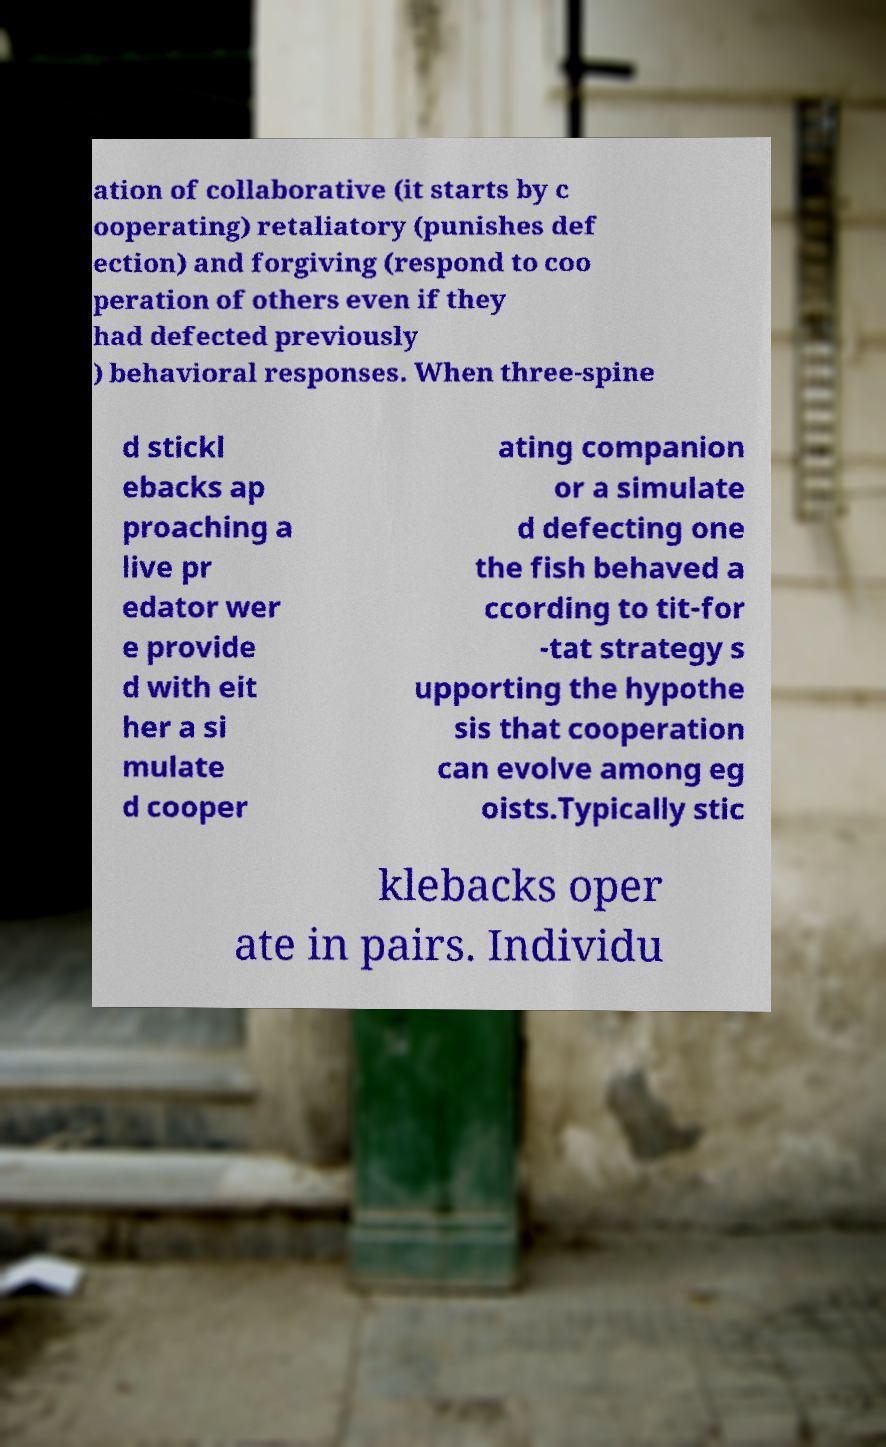What messages or text are displayed in this image? I need them in a readable, typed format. ation of collaborative (it starts by c ooperating) retaliatory (punishes def ection) and forgiving (respond to coo peration of others even if they had defected previously ) behavioral responses. When three-spine d stickl ebacks ap proaching a live pr edator wer e provide d with eit her a si mulate d cooper ating companion or a simulate d defecting one the fish behaved a ccording to tit-for -tat strategy s upporting the hypothe sis that cooperation can evolve among eg oists.Typically stic klebacks oper ate in pairs. Individu 